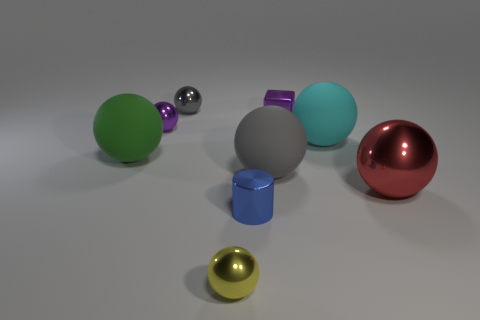Subtract all gray cubes. How many gray balls are left? 2 Subtract all tiny gray spheres. How many spheres are left? 6 Subtract 4 balls. How many balls are left? 3 Subtract all gray balls. How many balls are left? 5 Subtract all spheres. How many objects are left? 2 Subtract all purple balls. Subtract all blue cubes. How many balls are left? 6 Add 2 tiny shiny cubes. How many tiny shiny cubes are left? 3 Add 3 large metallic things. How many large metallic things exist? 4 Subtract 1 purple balls. How many objects are left? 8 Subtract all purple metallic things. Subtract all red metal spheres. How many objects are left? 6 